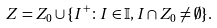Convert formula to latex. <formula><loc_0><loc_0><loc_500><loc_500>Z = Z _ { 0 } \cup \{ I ^ { + } \colon I \in \mathbb { I } , I \cap Z _ { 0 } \neq \emptyset \} .</formula> 